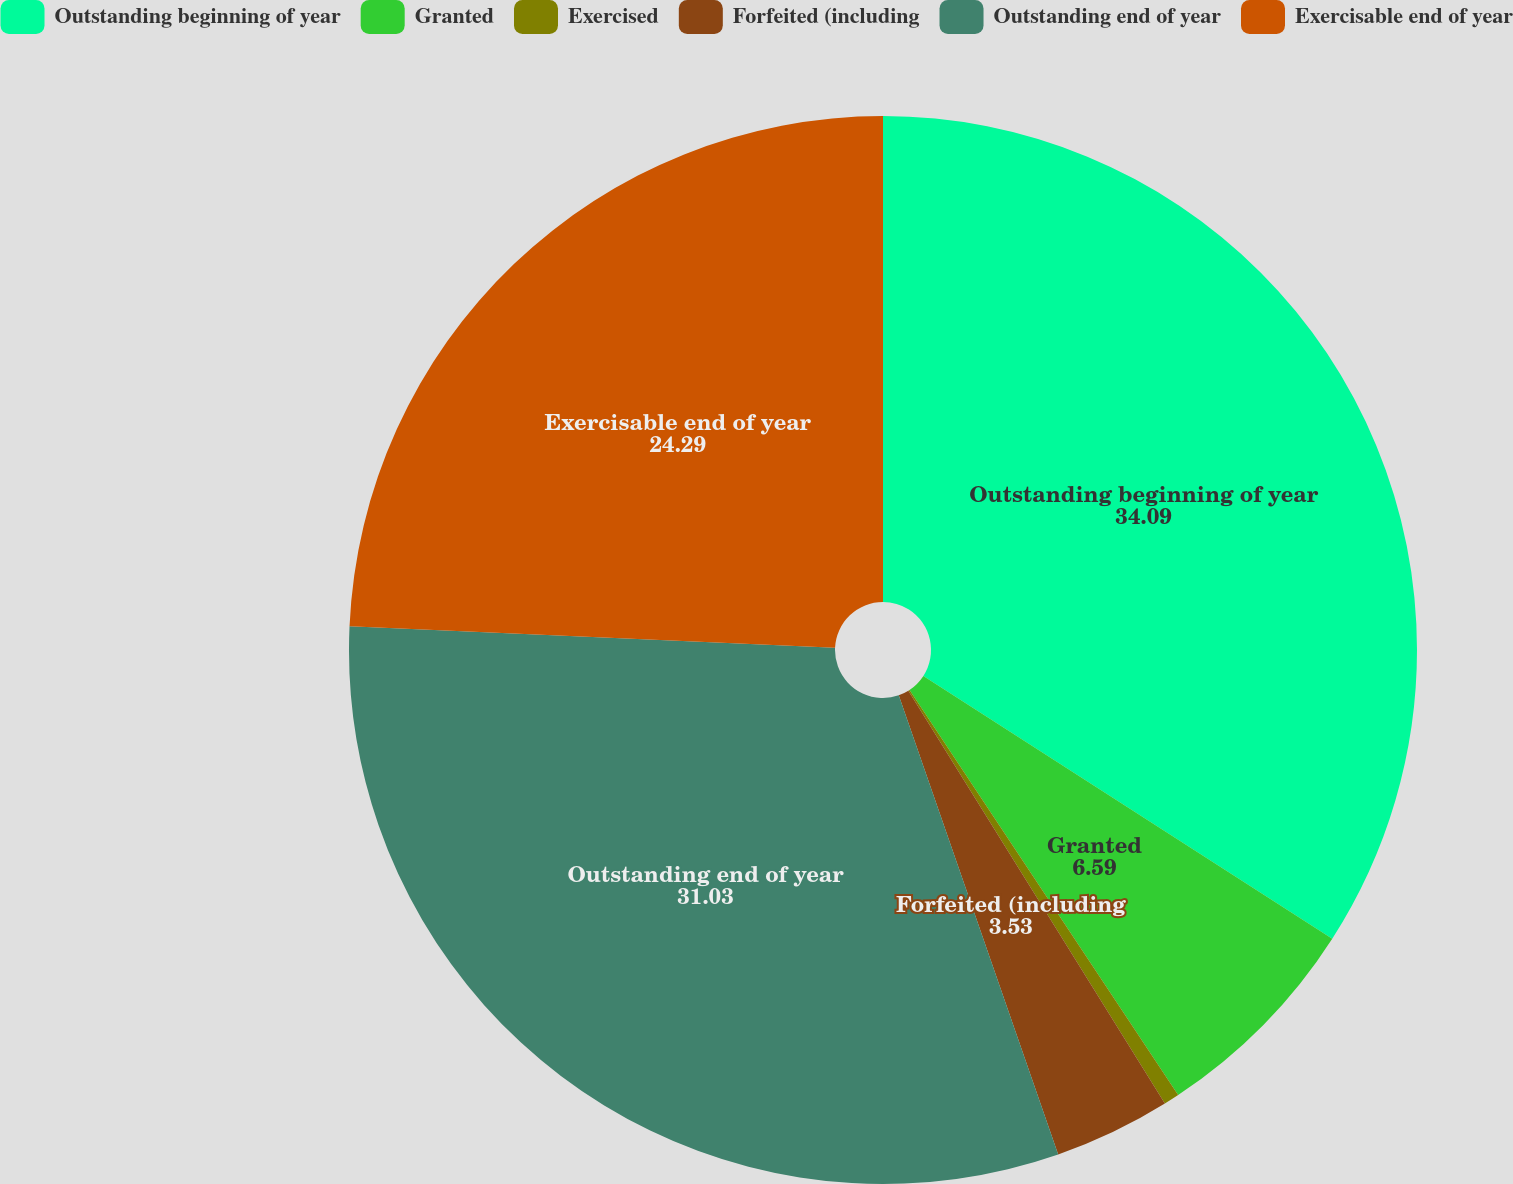Convert chart to OTSL. <chart><loc_0><loc_0><loc_500><loc_500><pie_chart><fcel>Outstanding beginning of year<fcel>Granted<fcel>Exercised<fcel>Forfeited (including<fcel>Outstanding end of year<fcel>Exercisable end of year<nl><fcel>34.09%<fcel>6.59%<fcel>0.47%<fcel>3.53%<fcel>31.03%<fcel>24.29%<nl></chart> 